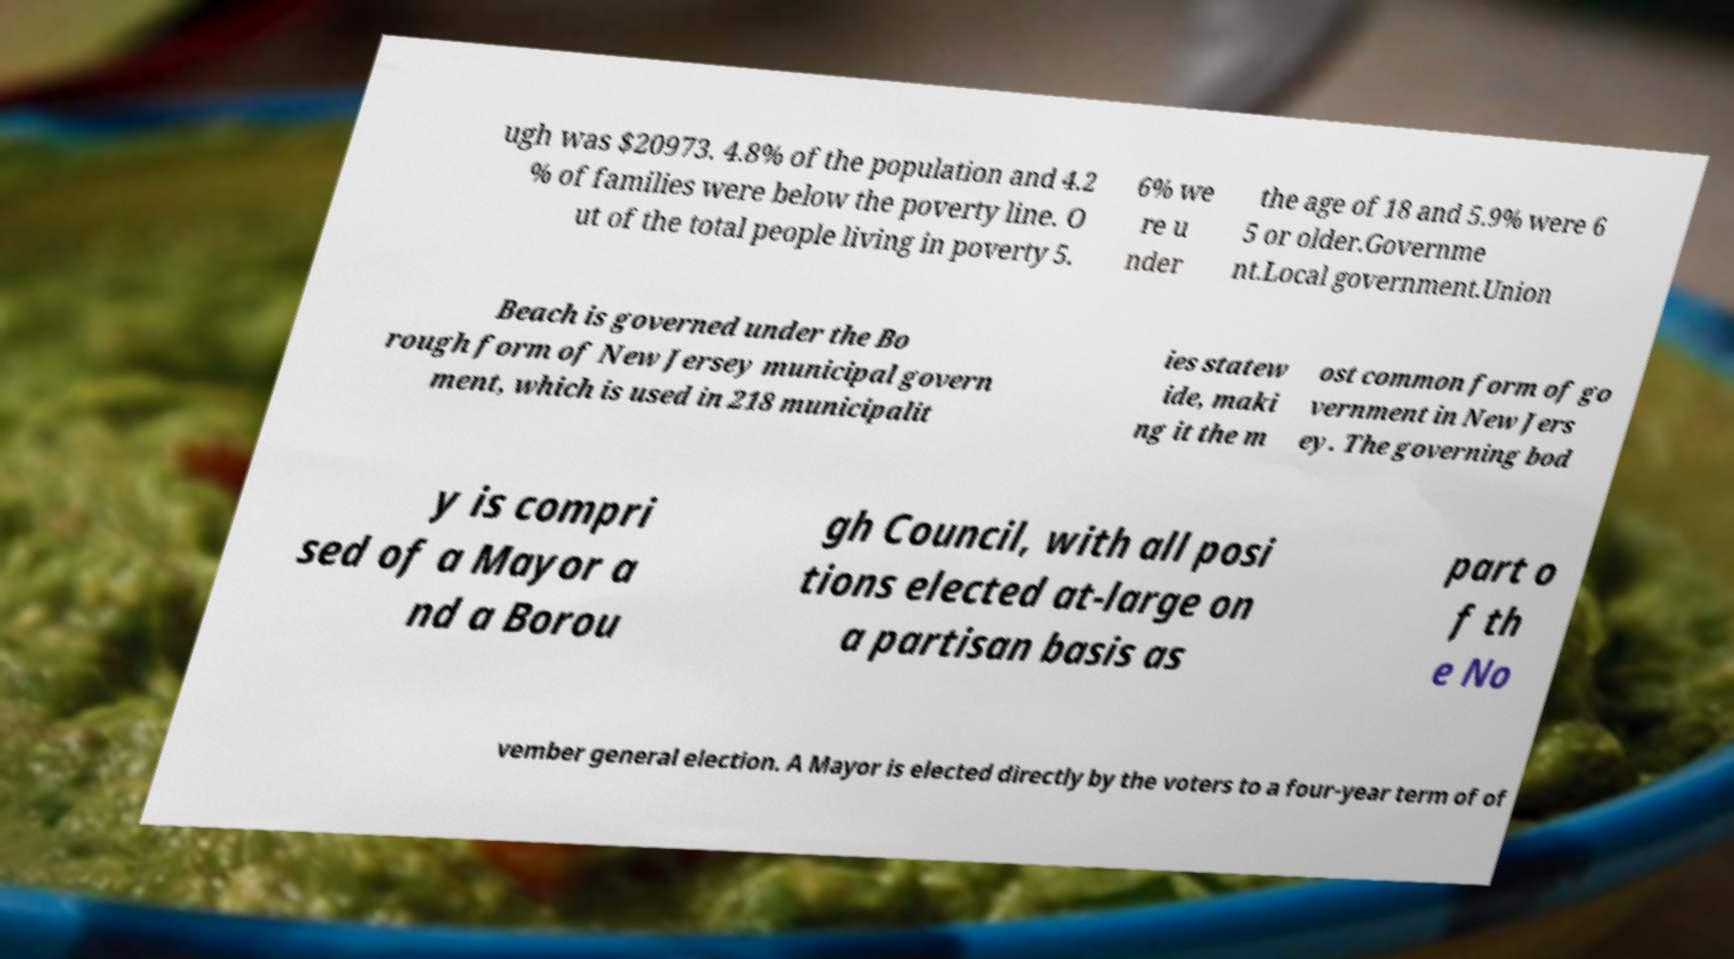For documentation purposes, I need the text within this image transcribed. Could you provide that? ugh was $20973. 4.8% of the population and 4.2 % of families were below the poverty line. O ut of the total people living in poverty 5. 6% we re u nder the age of 18 and 5.9% were 6 5 or older.Governme nt.Local government.Union Beach is governed under the Bo rough form of New Jersey municipal govern ment, which is used in 218 municipalit ies statew ide, maki ng it the m ost common form of go vernment in New Jers ey. The governing bod y is compri sed of a Mayor a nd a Borou gh Council, with all posi tions elected at-large on a partisan basis as part o f th e No vember general election. A Mayor is elected directly by the voters to a four-year term of of 